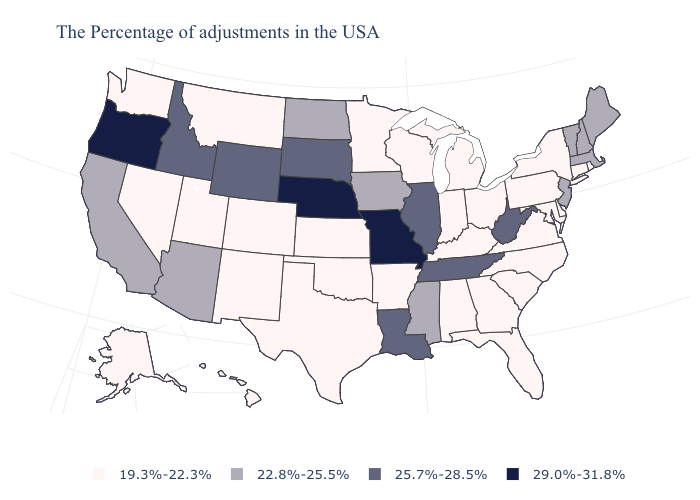Among the states that border Connecticut , which have the lowest value?
Quick response, please. Rhode Island, New York. Name the states that have a value in the range 29.0%-31.8%?
Be succinct. Missouri, Nebraska, Oregon. What is the lowest value in the West?
Concise answer only. 19.3%-22.3%. Does Michigan have the lowest value in the USA?
Be succinct. Yes. Name the states that have a value in the range 19.3%-22.3%?
Concise answer only. Rhode Island, Connecticut, New York, Delaware, Maryland, Pennsylvania, Virginia, North Carolina, South Carolina, Ohio, Florida, Georgia, Michigan, Kentucky, Indiana, Alabama, Wisconsin, Arkansas, Minnesota, Kansas, Oklahoma, Texas, Colorado, New Mexico, Utah, Montana, Nevada, Washington, Alaska, Hawaii. What is the highest value in the USA?
Keep it brief. 29.0%-31.8%. What is the value of Montana?
Keep it brief. 19.3%-22.3%. Which states hav the highest value in the West?
Short answer required. Oregon. Which states have the highest value in the USA?
Concise answer only. Missouri, Nebraska, Oregon. What is the lowest value in the MidWest?
Write a very short answer. 19.3%-22.3%. What is the lowest value in the Northeast?
Write a very short answer. 19.3%-22.3%. Name the states that have a value in the range 25.7%-28.5%?
Answer briefly. West Virginia, Tennessee, Illinois, Louisiana, South Dakota, Wyoming, Idaho. What is the value of Wyoming?
Be succinct. 25.7%-28.5%. Name the states that have a value in the range 25.7%-28.5%?
Short answer required. West Virginia, Tennessee, Illinois, Louisiana, South Dakota, Wyoming, Idaho. Is the legend a continuous bar?
Short answer required. No. 